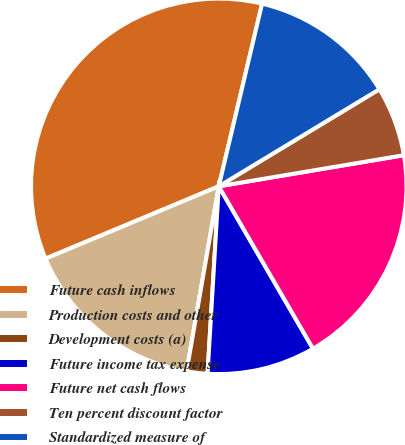Convert chart. <chart><loc_0><loc_0><loc_500><loc_500><pie_chart><fcel>Future cash inflows<fcel>Production costs and other<fcel>Development costs (a)<fcel>Future income tax expense<fcel>Future net cash flows<fcel>Ten percent discount factor<fcel>Standardized measure of<nl><fcel>35.0%<fcel>15.96%<fcel>1.79%<fcel>9.32%<fcel>19.28%<fcel>6.0%<fcel>12.64%<nl></chart> 